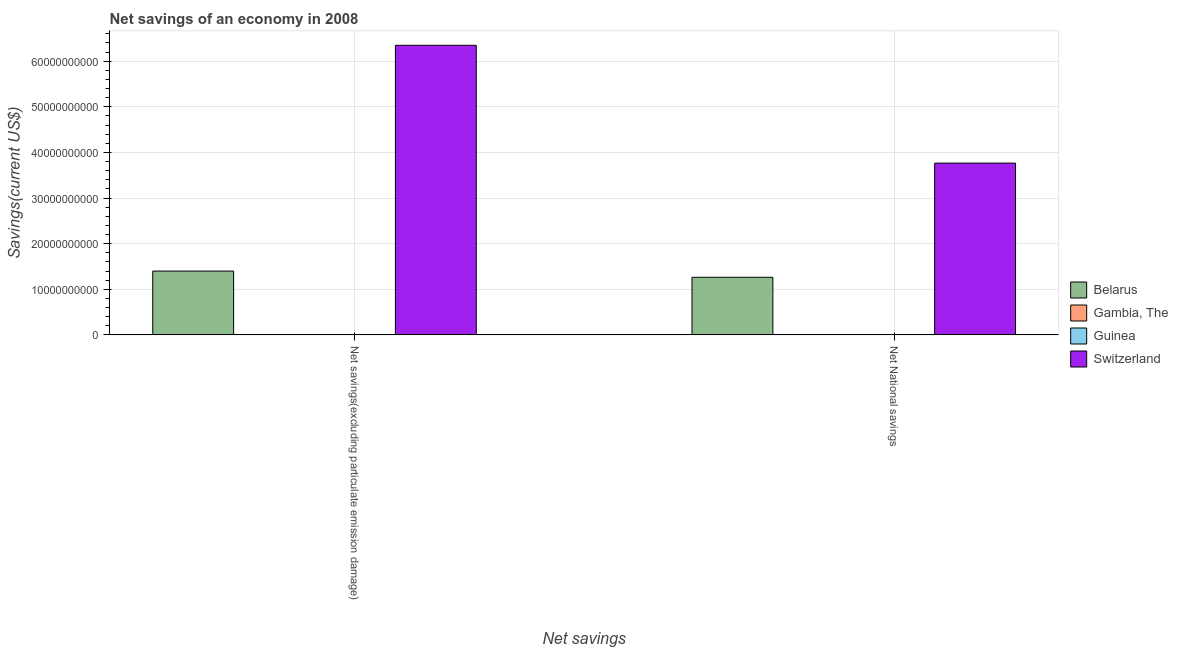How many different coloured bars are there?
Your answer should be compact. 2. How many groups of bars are there?
Your answer should be very brief. 2. Are the number of bars per tick equal to the number of legend labels?
Your answer should be compact. No. How many bars are there on the 1st tick from the left?
Offer a very short reply. 2. What is the label of the 2nd group of bars from the left?
Provide a succinct answer. Net National savings. What is the net savings(excluding particulate emission damage) in Switzerland?
Your response must be concise. 6.35e+1. Across all countries, what is the maximum net savings(excluding particulate emission damage)?
Provide a short and direct response. 6.35e+1. In which country was the net savings(excluding particulate emission damage) maximum?
Provide a short and direct response. Switzerland. What is the total net savings(excluding particulate emission damage) in the graph?
Provide a short and direct response. 7.75e+1. What is the difference between the net savings(excluding particulate emission damage) in Switzerland and that in Belarus?
Keep it short and to the point. 4.95e+1. What is the average net savings(excluding particulate emission damage) per country?
Offer a terse response. 1.94e+1. What is the difference between the net savings(excluding particulate emission damage) and net national savings in Belarus?
Your response must be concise. 1.36e+09. What is the ratio of the net savings(excluding particulate emission damage) in Switzerland to that in Belarus?
Your answer should be compact. 4.54. Are all the bars in the graph horizontal?
Provide a short and direct response. No. How many countries are there in the graph?
Offer a very short reply. 4. What is the difference between two consecutive major ticks on the Y-axis?
Your answer should be compact. 1.00e+1. Are the values on the major ticks of Y-axis written in scientific E-notation?
Offer a very short reply. No. Where does the legend appear in the graph?
Your response must be concise. Center right. What is the title of the graph?
Give a very brief answer. Net savings of an economy in 2008. Does "Japan" appear as one of the legend labels in the graph?
Provide a succinct answer. No. What is the label or title of the X-axis?
Make the answer very short. Net savings. What is the label or title of the Y-axis?
Provide a short and direct response. Savings(current US$). What is the Savings(current US$) in Belarus in Net savings(excluding particulate emission damage)?
Make the answer very short. 1.40e+1. What is the Savings(current US$) of Guinea in Net savings(excluding particulate emission damage)?
Give a very brief answer. 0. What is the Savings(current US$) in Switzerland in Net savings(excluding particulate emission damage)?
Offer a very short reply. 6.35e+1. What is the Savings(current US$) in Belarus in Net National savings?
Offer a terse response. 1.26e+1. What is the Savings(current US$) in Switzerland in Net National savings?
Offer a very short reply. 3.77e+1. Across all Net savings, what is the maximum Savings(current US$) of Belarus?
Provide a short and direct response. 1.40e+1. Across all Net savings, what is the maximum Savings(current US$) in Switzerland?
Make the answer very short. 6.35e+1. Across all Net savings, what is the minimum Savings(current US$) in Belarus?
Offer a terse response. 1.26e+1. Across all Net savings, what is the minimum Savings(current US$) of Switzerland?
Offer a very short reply. 3.77e+1. What is the total Savings(current US$) of Belarus in the graph?
Make the answer very short. 2.66e+1. What is the total Savings(current US$) in Switzerland in the graph?
Your answer should be very brief. 1.01e+11. What is the difference between the Savings(current US$) of Belarus in Net savings(excluding particulate emission damage) and that in Net National savings?
Your response must be concise. 1.36e+09. What is the difference between the Savings(current US$) in Switzerland in Net savings(excluding particulate emission damage) and that in Net National savings?
Your response must be concise. 2.58e+1. What is the difference between the Savings(current US$) of Belarus in Net savings(excluding particulate emission damage) and the Savings(current US$) of Switzerland in Net National savings?
Your response must be concise. -2.37e+1. What is the average Savings(current US$) of Belarus per Net savings?
Provide a succinct answer. 1.33e+1. What is the average Savings(current US$) of Switzerland per Net savings?
Your response must be concise. 5.06e+1. What is the difference between the Savings(current US$) in Belarus and Savings(current US$) in Switzerland in Net savings(excluding particulate emission damage)?
Your response must be concise. -4.95e+1. What is the difference between the Savings(current US$) of Belarus and Savings(current US$) of Switzerland in Net National savings?
Ensure brevity in your answer.  -2.50e+1. What is the ratio of the Savings(current US$) of Belarus in Net savings(excluding particulate emission damage) to that in Net National savings?
Keep it short and to the point. 1.11. What is the ratio of the Savings(current US$) of Switzerland in Net savings(excluding particulate emission damage) to that in Net National savings?
Ensure brevity in your answer.  1.69. What is the difference between the highest and the second highest Savings(current US$) of Belarus?
Make the answer very short. 1.36e+09. What is the difference between the highest and the second highest Savings(current US$) of Switzerland?
Offer a very short reply. 2.58e+1. What is the difference between the highest and the lowest Savings(current US$) of Belarus?
Give a very brief answer. 1.36e+09. What is the difference between the highest and the lowest Savings(current US$) of Switzerland?
Give a very brief answer. 2.58e+1. 